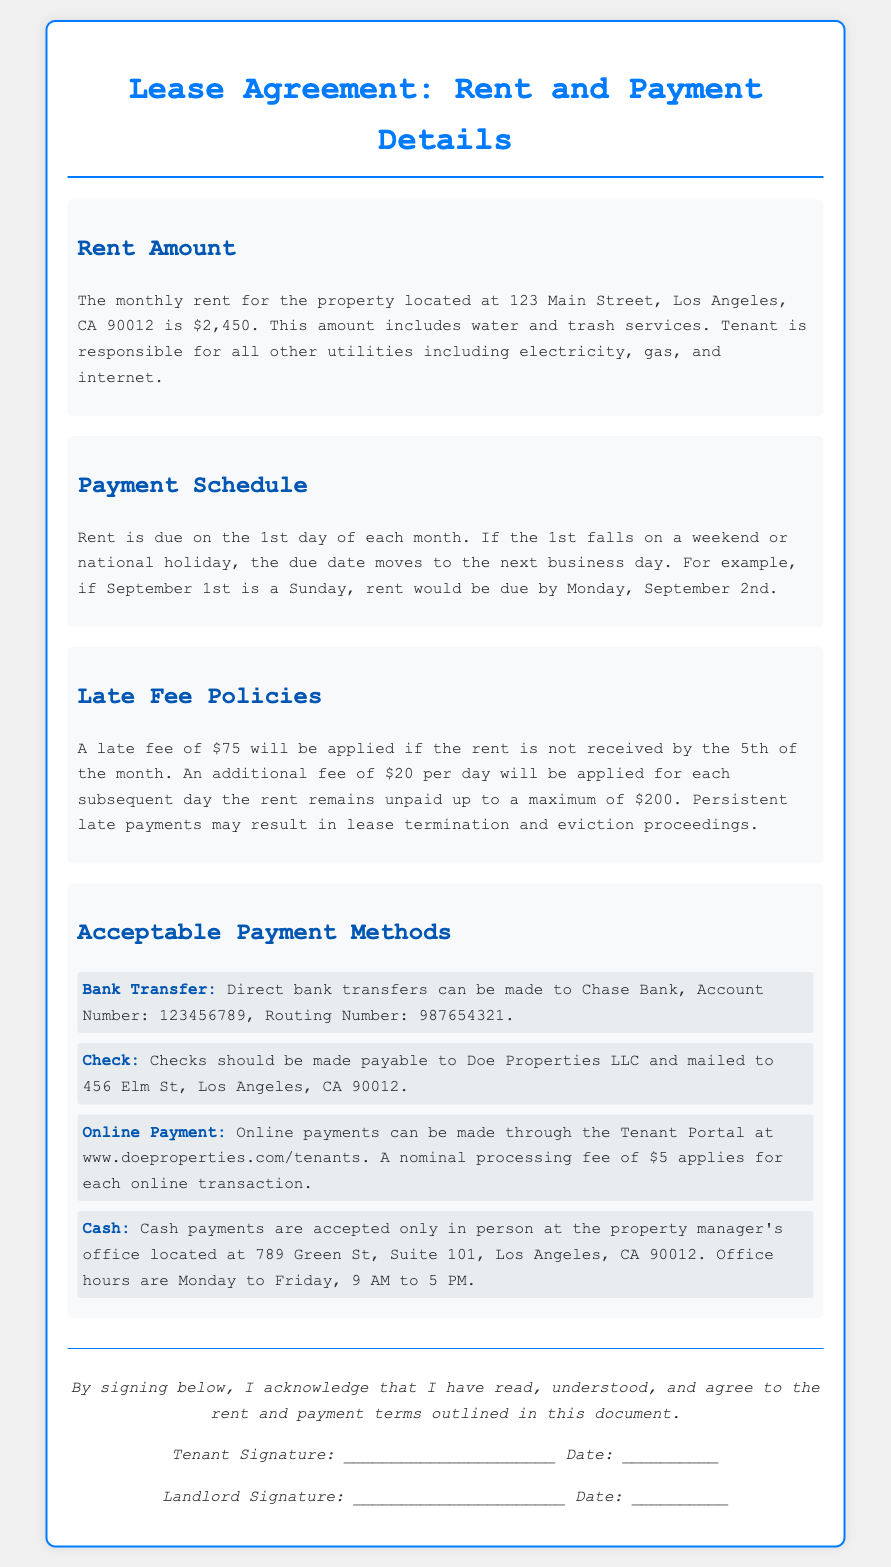What is the monthly rent amount? The monthly rent amount is specified in the document as $2,450 for the property.
Answer: $2,450 When is rent due each month? The document states that rent is due on the 1st day of each month.
Answer: 1st day What is the late fee if rent is not received by the 5th? The document specifies that a late fee of $75 will be applied if the rent is not paid by the 5th of the month.
Answer: $75 What is the additional late fee per day after the 5th? The document indicates that an additional fee of $20 per day will apply for each subsequent day the rent remains unpaid.
Answer: $20 What is the maximum late fee that can be imposed? The document mentions that the additional late fees will accumulate up to a maximum of $200.
Answer: $200 What payment methods are acceptable? The document lists acceptable payment methods including Bank Transfer, Check, Online Payment, and Cash.
Answer: Bank Transfer, Check, Online Payment, Cash Where should checks be mailed? The document states that checks should be mailed to 456 Elm St, Los Angeles, CA 90012.
Answer: 456 Elm St, Los Angeles, CA 90012 Is there a processing fee for online payments? The document specifies that a nominal processing fee of $5 applies for each online transaction.
Answer: $5 What are the office hours for cash payments? The document indicates that cash payments can be made in person during office hours from Monday to Friday, 9 AM to 5 PM.
Answer: Monday to Friday, 9 AM to 5 PM 